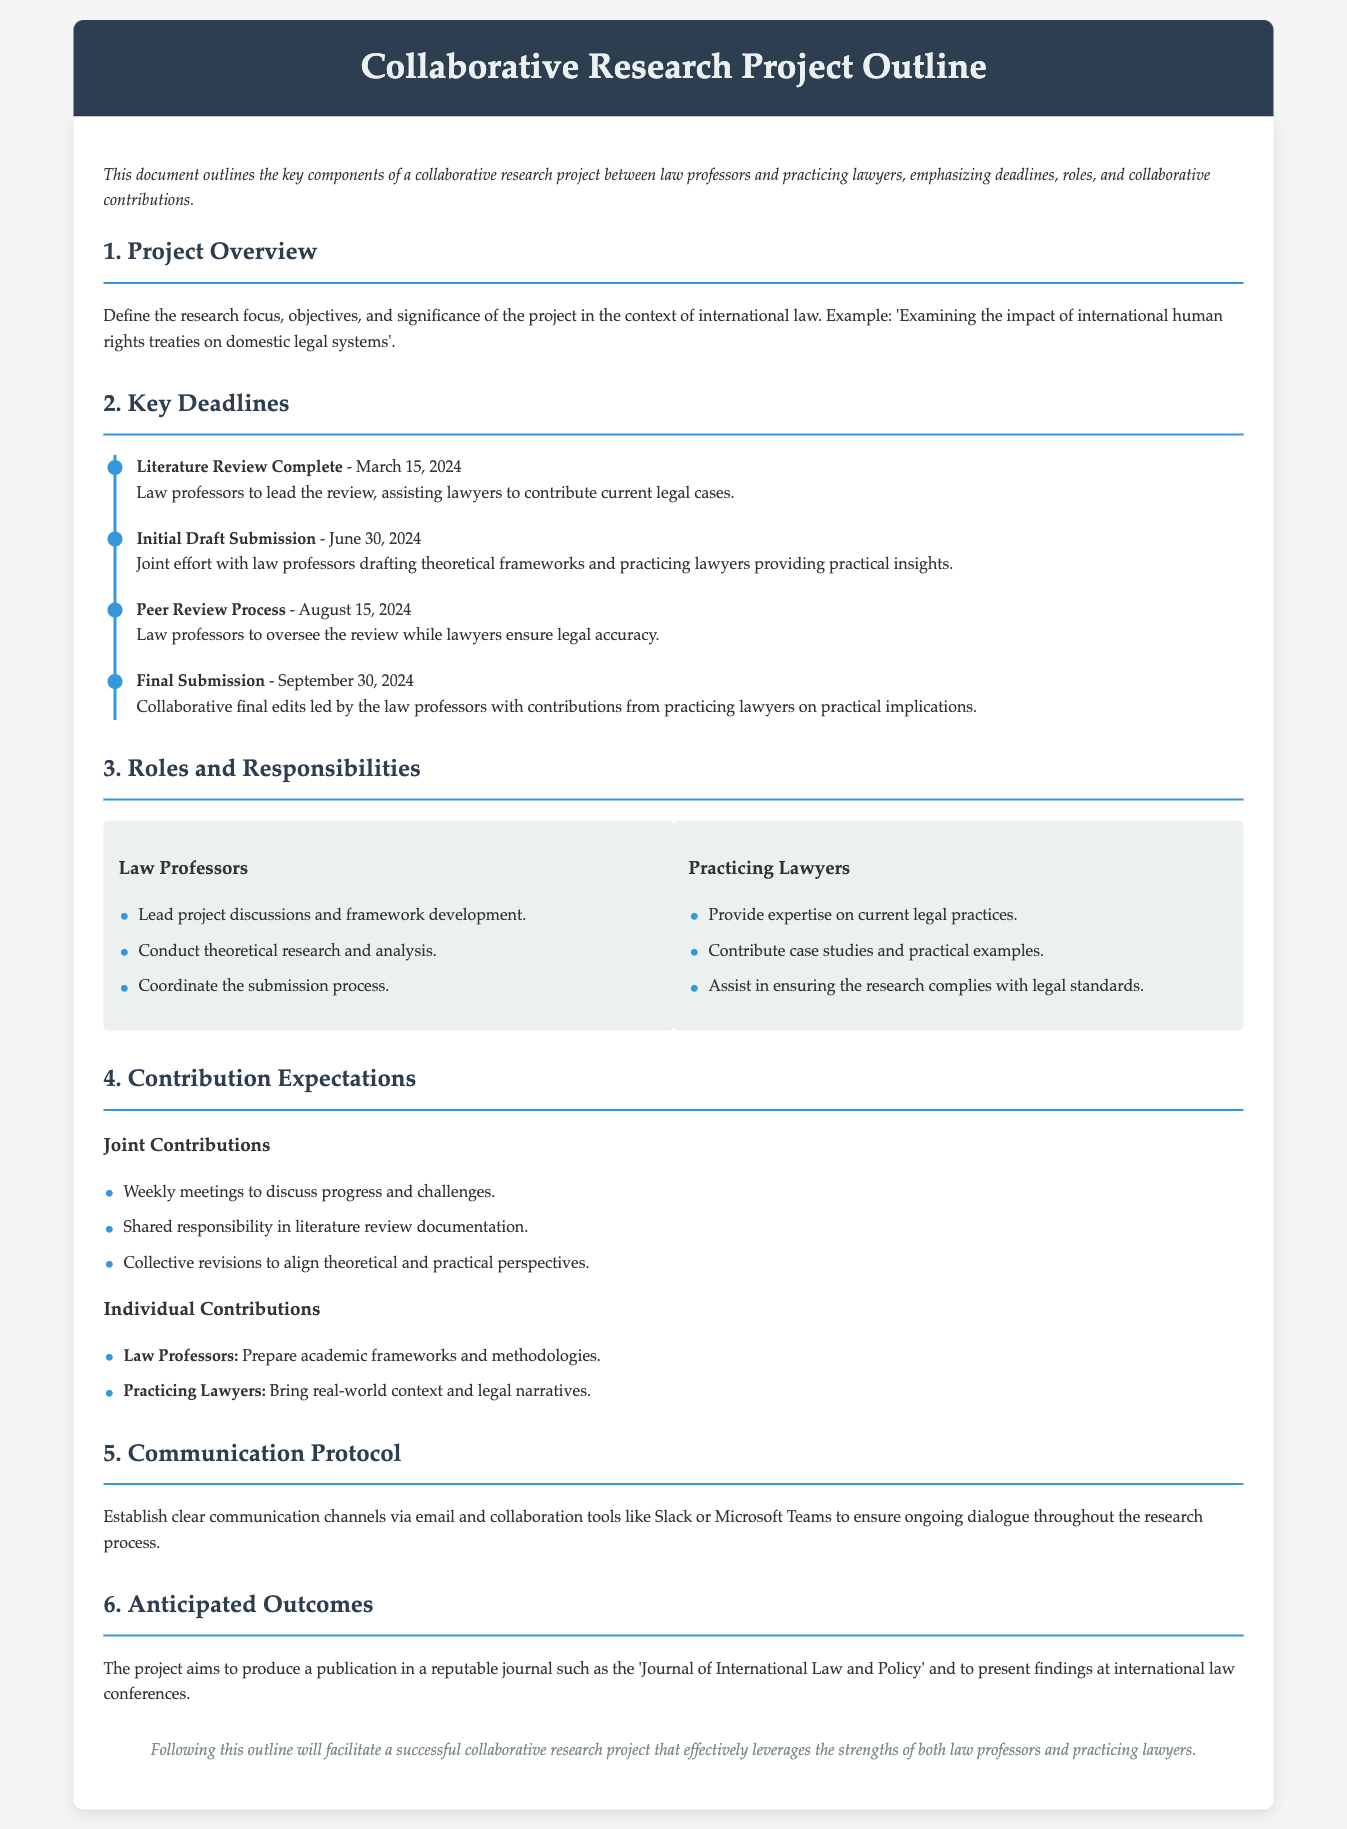what is the deadline for the Literature Review Completion? The document specifies the date for the Literature Review Completion as March 15, 2024.
Answer: March 15, 2024 who oversees the Peer Review Process? According to the document, Law professors oversee the Peer Review Process.
Answer: Law professors what are the two roles defined in the project? The document identifies two roles: Law Professors and Practicing Lawyers.
Answer: Law Professors and Practicing Lawyers when is the Final Submission date? The document states the Final Submission date is September 30, 2024.
Answer: September 30, 2024 what is one expectation for Joint Contributions? One expectation for Joint Contributions is weekly meetings to discuss progress and challenges.
Answer: Weekly meetings to discuss progress and challenges what journal does the project aim to publish in? The anticipated publication for the project is in the 'Journal of International Law and Policy'.
Answer: Journal of International Law and Policy what type of research areas do Law Professors focus on? Law Professors focus on theoretical research and analysis as indicated in their responsibilities.
Answer: Theoretical research and analysis how often should meetings occur according to the document? The document mentions weekly meetings should occur.
Answer: Weekly what tools are suggested for communication? The document suggests using email and collaboration tools like Slack or Microsoft Teams for communication.
Answer: Slack or Microsoft Teams 